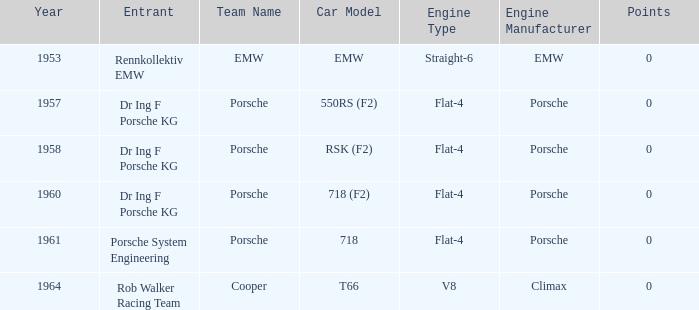What engine did the porsche 718 chassis use? Porsche Flat-4. 